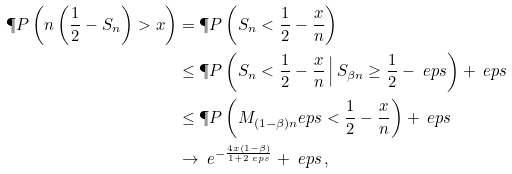<formula> <loc_0><loc_0><loc_500><loc_500>\P P \left ( n \left ( \frac { 1 } { 2 } - S _ { n } \right ) > x \right ) & = \P P \left ( S _ { n } < \frac { 1 } { 2 } - \frac { x } { n } \right ) \\ & \leq \P P \left ( S _ { n } < \frac { 1 } { 2 } - \frac { x } { n } \, \Big | \, S _ { \beta n } \geq \frac { 1 } { 2 } - \ e p s \right ) + \ e p s \\ & \leq \P P \left ( M _ { ( 1 - \beta ) n } ^ { \ } e p s < \frac { 1 } { 2 } - \frac { x } { n } \right ) + \ e p s \\ & \to \ e ^ { - \frac { 4 x ( 1 - \beta ) } { 1 + 2 \ e p s } } + \ e p s \, ,</formula> 